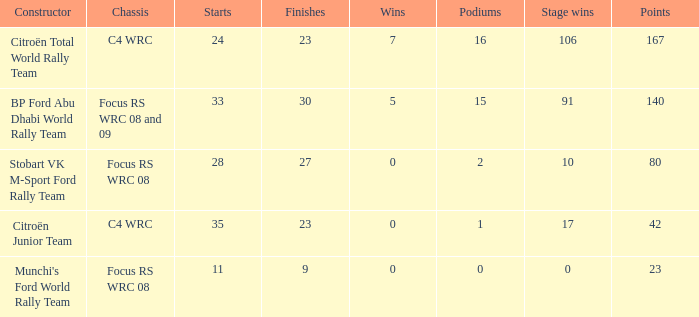What is the peak points when the framework is focus rs wrc 08 and 09 and the stage successes surpass 91? None. 